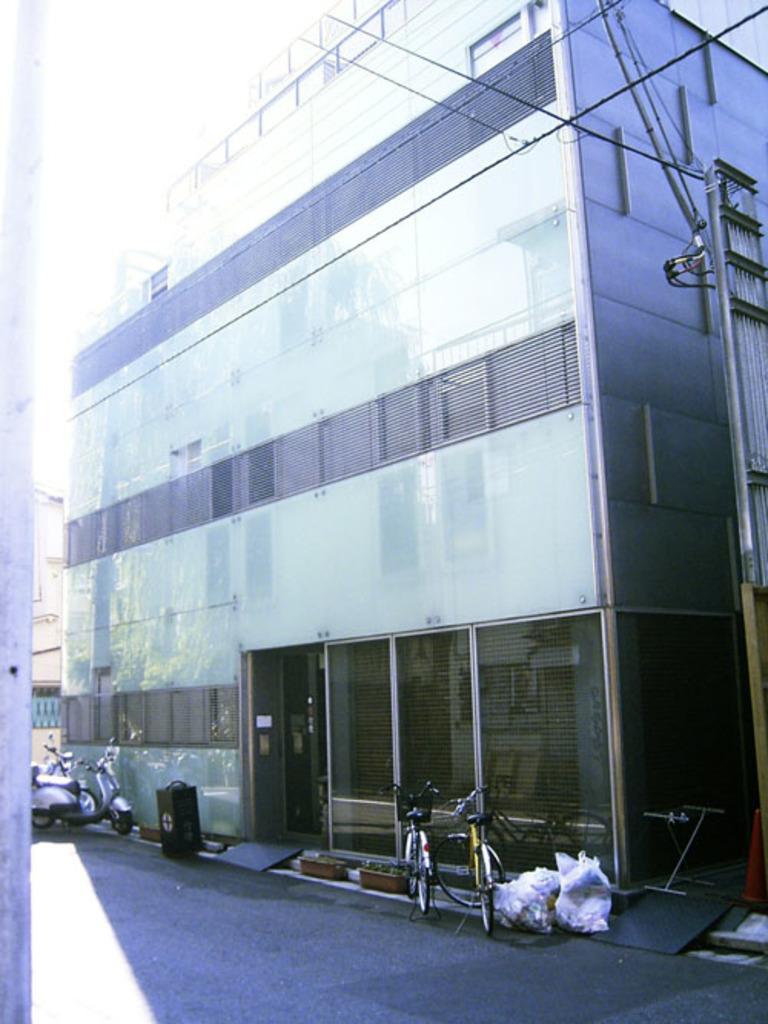In one or two sentences, can you explain what this image depicts? In the center of the image there is a building. At the bottom of the image there is road. There are vehicles on the road. There are bicycles. At the top of the image there is sky. To the left side of the image there is a pole. 